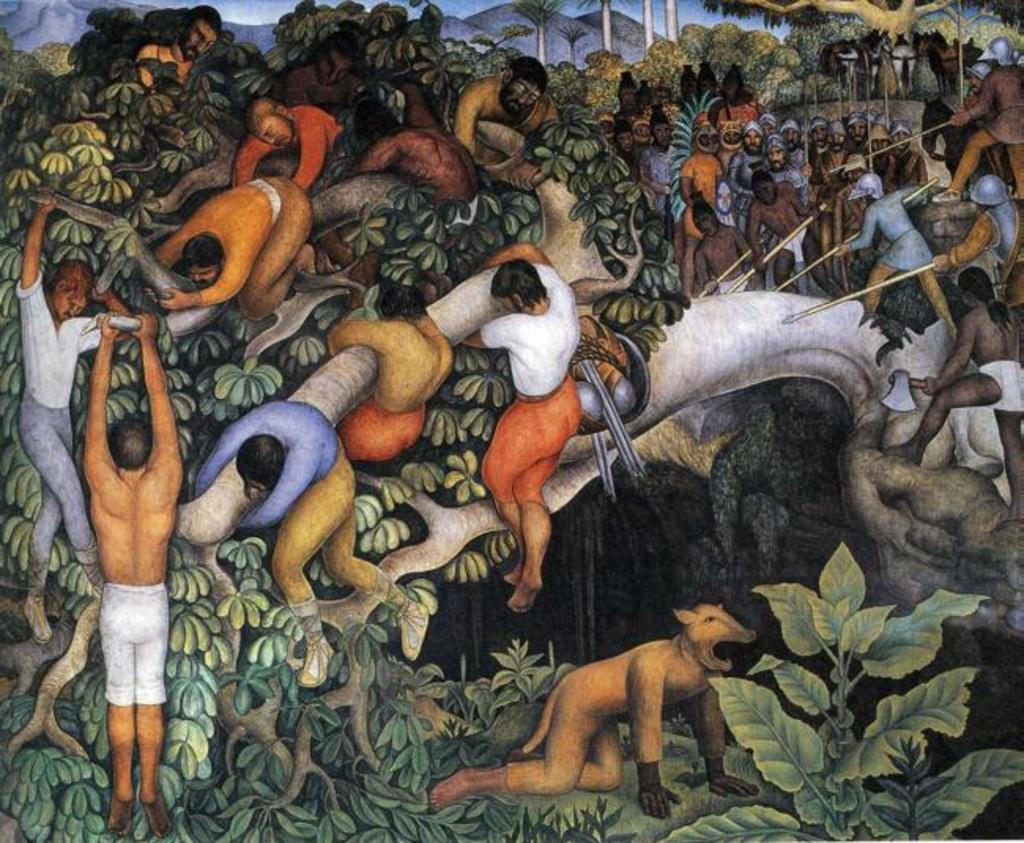What type of artwork is depicted in the image? The image is a painting. What is the main subject of the painting? There is a group of persons in the painting. What type of natural environment is present in the painting? There are trees and hills in the background of the painting. What can be seen in the sky in the painting? The sky is visible in the background of the painting. What type of brass instrument is being played by the girl in the painting? There is no girl or brass instrument present in the painting. What type of rhythm can be heard in the painting? The painting is a visual art form and does not have an audible rhythm. 